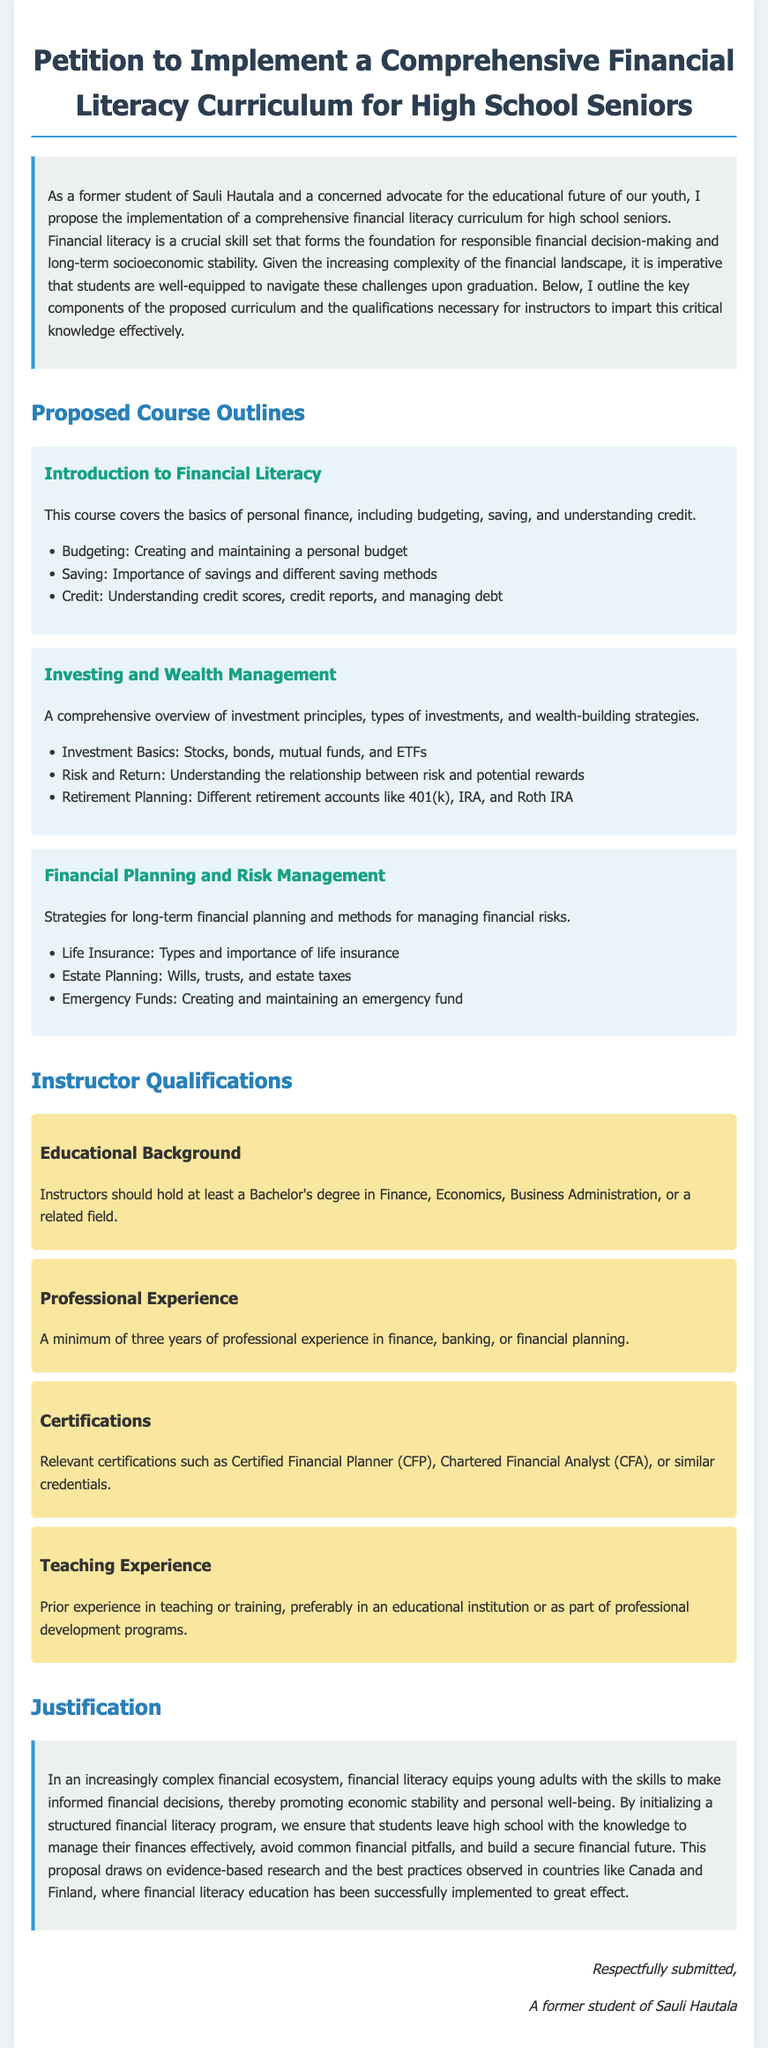What is the proposed financial literacy curriculum for high school seniors? The document proposes a comprehensive financial literacy curriculum aimed at equipping high school seniors with essential financial skills.
Answer: Comprehensive financial literacy curriculum What should instructors hold as a minimum educational qualification? Minimum educational qualifications for instructors are specified in the curriculum proposal.
Answer: Bachelor's degree How many courses are proposed in the curriculum? The document lists three specific courses as part of the curriculum.
Answer: Three What is the focus of the "Investing and Wealth Management" course? The document outlines the topics that will be covered in the Investing and Wealth Management course.
Answer: Investment principles How many years of professional experience are required for instructors? The curriculum specifies the minimum years of professional experience needed for instructors.
Answer: Three years What is one of the instructor certifications mentioned? Relevant certifications are necessary for instructors, one of which is noted in the petition.
Answer: Certified Financial Planner What type of planning is covered in the "Financial Planning and Risk Management" course? The document specifies methods for managing financial risks among other topics in this course.
Answer: Financial planning What evidence is used to support the curriculum? The justification section refers to successful examples from other countries to support its claims.
Answer: Canada and Finland 